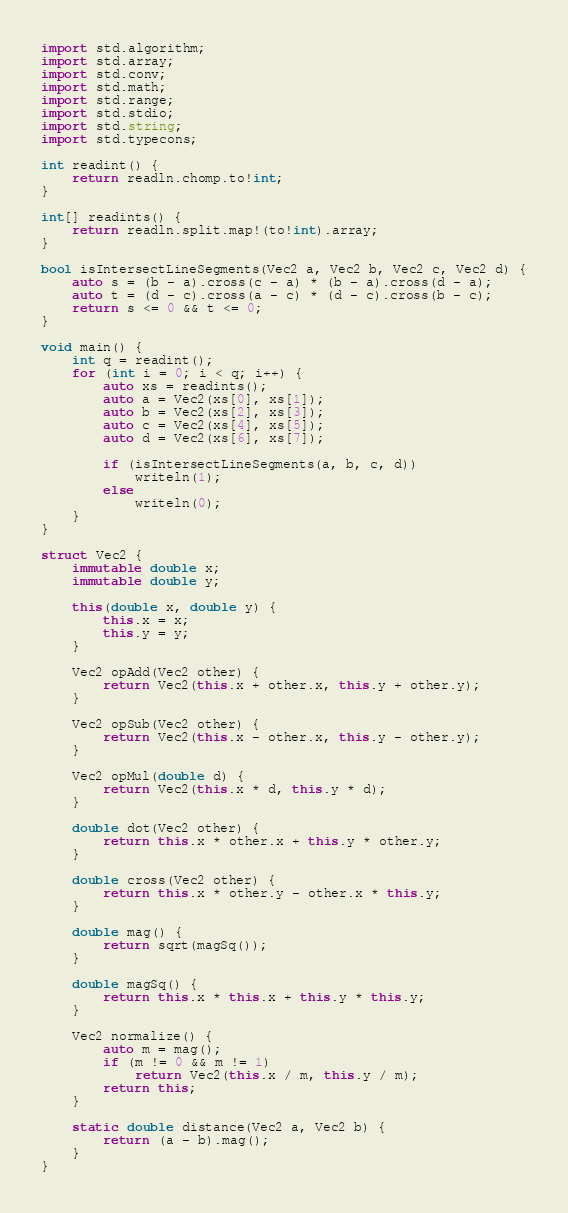<code> <loc_0><loc_0><loc_500><loc_500><_D_>import std.algorithm;
import std.array;
import std.conv;
import std.math;
import std.range;
import std.stdio;
import std.string;
import std.typecons;

int readint() {
    return readln.chomp.to!int;
}

int[] readints() {
    return readln.split.map!(to!int).array;
}

bool isIntersectLineSegments(Vec2 a, Vec2 b, Vec2 c, Vec2 d) {
    auto s = (b - a).cross(c - a) * (b - a).cross(d - a);
    auto t = (d - c).cross(a - c) * (d - c).cross(b - c);
    return s <= 0 && t <= 0;
}

void main() {
    int q = readint();
    for (int i = 0; i < q; i++) {
        auto xs = readints();
        auto a = Vec2(xs[0], xs[1]);
        auto b = Vec2(xs[2], xs[3]);
        auto c = Vec2(xs[4], xs[5]);
        auto d = Vec2(xs[6], xs[7]);

        if (isIntersectLineSegments(a, b, c, d))
            writeln(1);
        else
            writeln(0);
    }
}

struct Vec2 {
    immutable double x;
    immutable double y;

    this(double x, double y) {
        this.x = x;
        this.y = y;
    }

    Vec2 opAdd(Vec2 other) {
        return Vec2(this.x + other.x, this.y + other.y);
    }

    Vec2 opSub(Vec2 other) {
        return Vec2(this.x - other.x, this.y - other.y);
    }

    Vec2 opMul(double d) {
        return Vec2(this.x * d, this.y * d);
    }

    double dot(Vec2 other) {
        return this.x * other.x + this.y * other.y;
    }

    double cross(Vec2 other) {
        return this.x * other.y - other.x * this.y;
    }

    double mag() {
        return sqrt(magSq());
    }

    double magSq() {
        return this.x * this.x + this.y * this.y;
    }

    Vec2 normalize() {
        auto m = mag();
        if (m != 0 && m != 1)
            return Vec2(this.x / m, this.y / m);
        return this;
    }

    static double distance(Vec2 a, Vec2 b) {
        return (a - b).mag();
    }
}</code> 